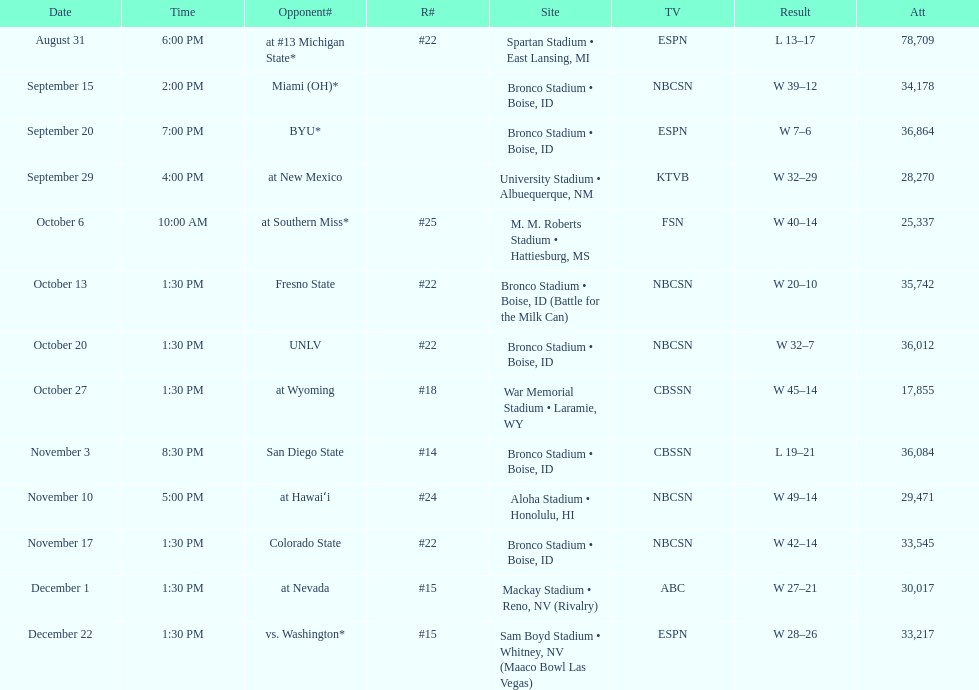What are the opponents to the  2012 boise state broncos football team? At #13 michigan state*, miami (oh)*, byu*, at new mexico, at southern miss*, fresno state, unlv, at wyoming, san diego state, at hawaiʻi, colorado state, at nevada, vs. washington*. Which is the highest ranked of the teams? San Diego State. 